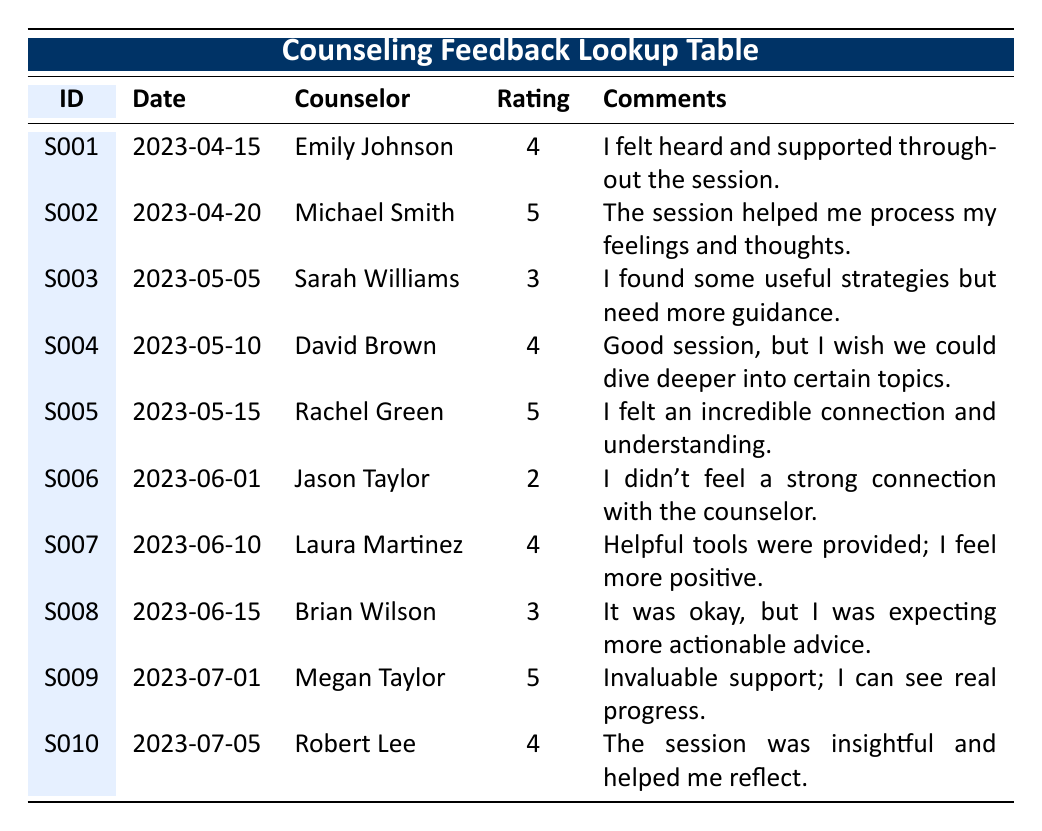What was the highest effectiveness rating given in the feedback? The highest effectiveness rating in the table is 5. This can be found by scanning the "Rating" column and identifying the maximum value across all the entries.
Answer: 5 How many sessions received a rating of 4? There are four instances of a rating of 4 in the "Rating" column. By counting these entries, we can determine the total. The sessions by Emily Johnson, David Brown, Laura Martinez, and Robert Lee all had this rating.
Answer: 4 Which counselor received the most "excellent" ratings (5)? Two counselors, Michael Smith and Rachel Green, each received a rating of 5. To answer this, we check who received the rating of 5 in the "Rating" column and find there are two counselors with that rating.
Answer: Michael Smith and Rachel Green Did any survivor give a rating of 2, and if so, who was the counselor? Yes, survivor S006 gave a rating of 2, and the counselor was Jason Taylor. We refer to the table and locate the row where the rating is 2 to determine the counselor's name.
Answer: Yes, Jason Taylor What is the average effectiveness rating across all sessions? To find the average effectiveness rating, add all the ratings together: (4 + 5 + 3 + 4 + 5 + 2 + 4 + 3 + 5 + 4) = 43. Since there are 10 entries, we divide 43 by 10: 43/10 = 4.3.
Answer: 4.3 How many feedback comments expressed a need for more guidance or depth? Two comments reflect a need for more guidance or depth. The comments by Sarah Williams and David Brown indicate this need by specifically mentioning usefulness and a desire to dive deeper.
Answer: 2 Was there any session where the survivor felt an incredible connection with the counselor? Yes, survivor S005 expressed an incredible connection and understanding in their feedback comment regarding Rachel Green. To verify, read the comments section and find S005’s remark.
Answer: Yes Which session had the latest date, and what was the effectiveness rating for that session? The latest session date is 2023-07-05, corresponding to survivor S010. The effectiveness rating for this session is 4. We find the last entry in the "Date" column to answer this question accurately.
Answer: 4 